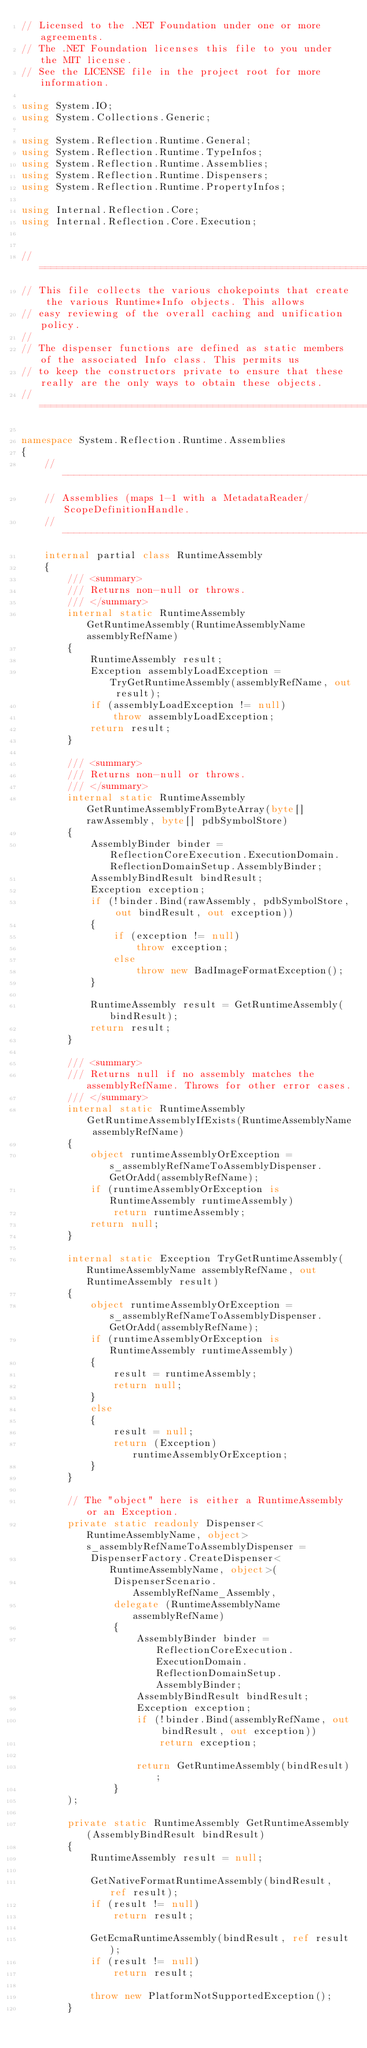<code> <loc_0><loc_0><loc_500><loc_500><_C#_>// Licensed to the .NET Foundation under one or more agreements.
// The .NET Foundation licenses this file to you under the MIT license.
// See the LICENSE file in the project root for more information.

using System.IO;
using System.Collections.Generic;

using System.Reflection.Runtime.General;
using System.Reflection.Runtime.TypeInfos;
using System.Reflection.Runtime.Assemblies;
using System.Reflection.Runtime.Dispensers;
using System.Reflection.Runtime.PropertyInfos;

using Internal.Reflection.Core;
using Internal.Reflection.Core.Execution;


//=================================================================================================================
// This file collects the various chokepoints that create the various Runtime*Info objects. This allows
// easy reviewing of the overall caching and unification policy.
//
// The dispenser functions are defined as static members of the associated Info class. This permits us
// to keep the constructors private to ensure that these really are the only ways to obtain these objects.
//=================================================================================================================

namespace System.Reflection.Runtime.Assemblies
{
    //-----------------------------------------------------------------------------------------------------------
    // Assemblies (maps 1-1 with a MetadataReader/ScopeDefinitionHandle.
    //-----------------------------------------------------------------------------------------------------------
    internal partial class RuntimeAssembly
    {
        /// <summary>
        /// Returns non-null or throws.
        /// </summary>
        internal static RuntimeAssembly GetRuntimeAssembly(RuntimeAssemblyName assemblyRefName)
        {
            RuntimeAssembly result;
            Exception assemblyLoadException = TryGetRuntimeAssembly(assemblyRefName, out result);
            if (assemblyLoadException != null)
                throw assemblyLoadException;
            return result;
        }

        /// <summary>
        /// Returns non-null or throws.
        /// </summary>
        internal static RuntimeAssembly GetRuntimeAssemblyFromByteArray(byte[] rawAssembly, byte[] pdbSymbolStore)
        {
            AssemblyBinder binder = ReflectionCoreExecution.ExecutionDomain.ReflectionDomainSetup.AssemblyBinder;
            AssemblyBindResult bindResult;
            Exception exception;
            if (!binder.Bind(rawAssembly, pdbSymbolStore, out bindResult, out exception))
            {
                if (exception != null)
                    throw exception;
                else
                    throw new BadImageFormatException();
            }

            RuntimeAssembly result = GetRuntimeAssembly(bindResult);
            return result;
        }

        /// <summary>
        /// Returns null if no assembly matches the assemblyRefName. Throws for other error cases.
        /// </summary>
        internal static RuntimeAssembly GetRuntimeAssemblyIfExists(RuntimeAssemblyName assemblyRefName)
        {
            object runtimeAssemblyOrException = s_assemblyRefNameToAssemblyDispenser.GetOrAdd(assemblyRefName);
            if (runtimeAssemblyOrException is RuntimeAssembly runtimeAssembly)
                return runtimeAssembly;
            return null;
        }

        internal static Exception TryGetRuntimeAssembly(RuntimeAssemblyName assemblyRefName, out RuntimeAssembly result)
        {
            object runtimeAssemblyOrException = s_assemblyRefNameToAssemblyDispenser.GetOrAdd(assemblyRefName);
            if (runtimeAssemblyOrException is RuntimeAssembly runtimeAssembly)
            {
                result = runtimeAssembly;
                return null;
            }
            else
            {
                result = null;
                return (Exception)runtimeAssemblyOrException;
            }
        }

        // The "object" here is either a RuntimeAssembly or an Exception.
        private static readonly Dispenser<RuntimeAssemblyName, object> s_assemblyRefNameToAssemblyDispenser =
            DispenserFactory.CreateDispenser<RuntimeAssemblyName, object>(
                DispenserScenario.AssemblyRefName_Assembly,
                delegate (RuntimeAssemblyName assemblyRefName)
                {
                    AssemblyBinder binder = ReflectionCoreExecution.ExecutionDomain.ReflectionDomainSetup.AssemblyBinder;
                    AssemblyBindResult bindResult;
                    Exception exception;
                    if (!binder.Bind(assemblyRefName, out bindResult, out exception))
                        return exception;

                    return GetRuntimeAssembly(bindResult);
                }
        );

        private static RuntimeAssembly GetRuntimeAssembly(AssemblyBindResult bindResult)
        {
            RuntimeAssembly result = null;

            GetNativeFormatRuntimeAssembly(bindResult, ref result);
            if (result != null)
                return result;

            GetEcmaRuntimeAssembly(bindResult, ref result);
            if (result != null)
                return result;

            throw new PlatformNotSupportedException();
        }
</code> 